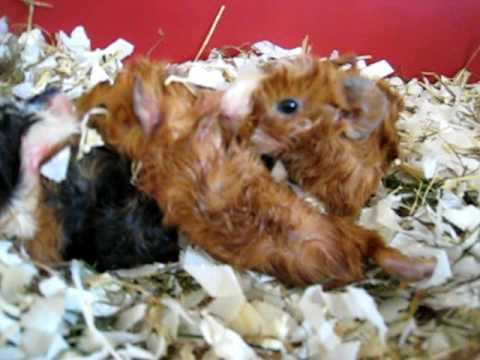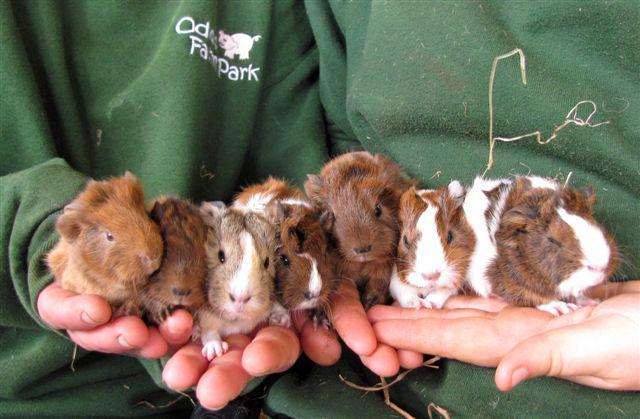The first image is the image on the left, the second image is the image on the right. Considering the images on both sides, is "At least one guinea pig is looking straight ahead." valid? Answer yes or no. Yes. The first image is the image on the left, the second image is the image on the right. Assess this claim about the two images: "there are guinea pigs on straw hay in a wooden pen". Correct or not? Answer yes or no. No. 